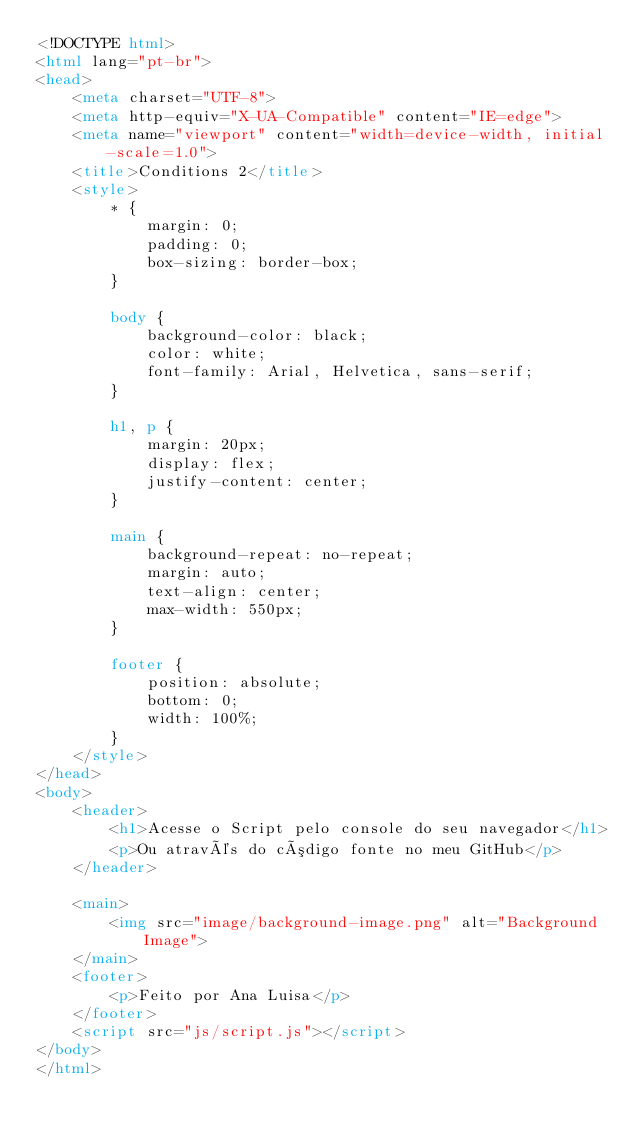Convert code to text. <code><loc_0><loc_0><loc_500><loc_500><_HTML_><!DOCTYPE html>
<html lang="pt-br">
<head>
    <meta charset="UTF-8">
    <meta http-equiv="X-UA-Compatible" content="IE=edge">
    <meta name="viewport" content="width=device-width, initial-scale=1.0">
    <title>Conditions 2</title>
    <style>
        * {
            margin: 0;
            padding: 0;
            box-sizing: border-box;
        }

        body {
            background-color: black;
            color: white;
            font-family: Arial, Helvetica, sans-serif;
        }

        h1, p {
            margin: 20px;
            display: flex;
            justify-content: center;
        }

        main {
            background-repeat: no-repeat;
            margin: auto;
            text-align: center;
            max-width: 550px;
        }

        footer {
            position: absolute;
            bottom: 0;
            width: 100%;
        }
    </style>
</head>
<body>
    <header>
        <h1>Acesse o Script pelo console do seu navegador</h1>
        <p>Ou através do código fonte no meu GitHub</p>
    </header>

    <main>
        <img src="image/background-image.png" alt="Background Image">
    </main>
    <footer>
        <p>Feito por Ana Luisa</p>
    </footer>
    <script src="js/script.js"></script>
</body>
</html></code> 